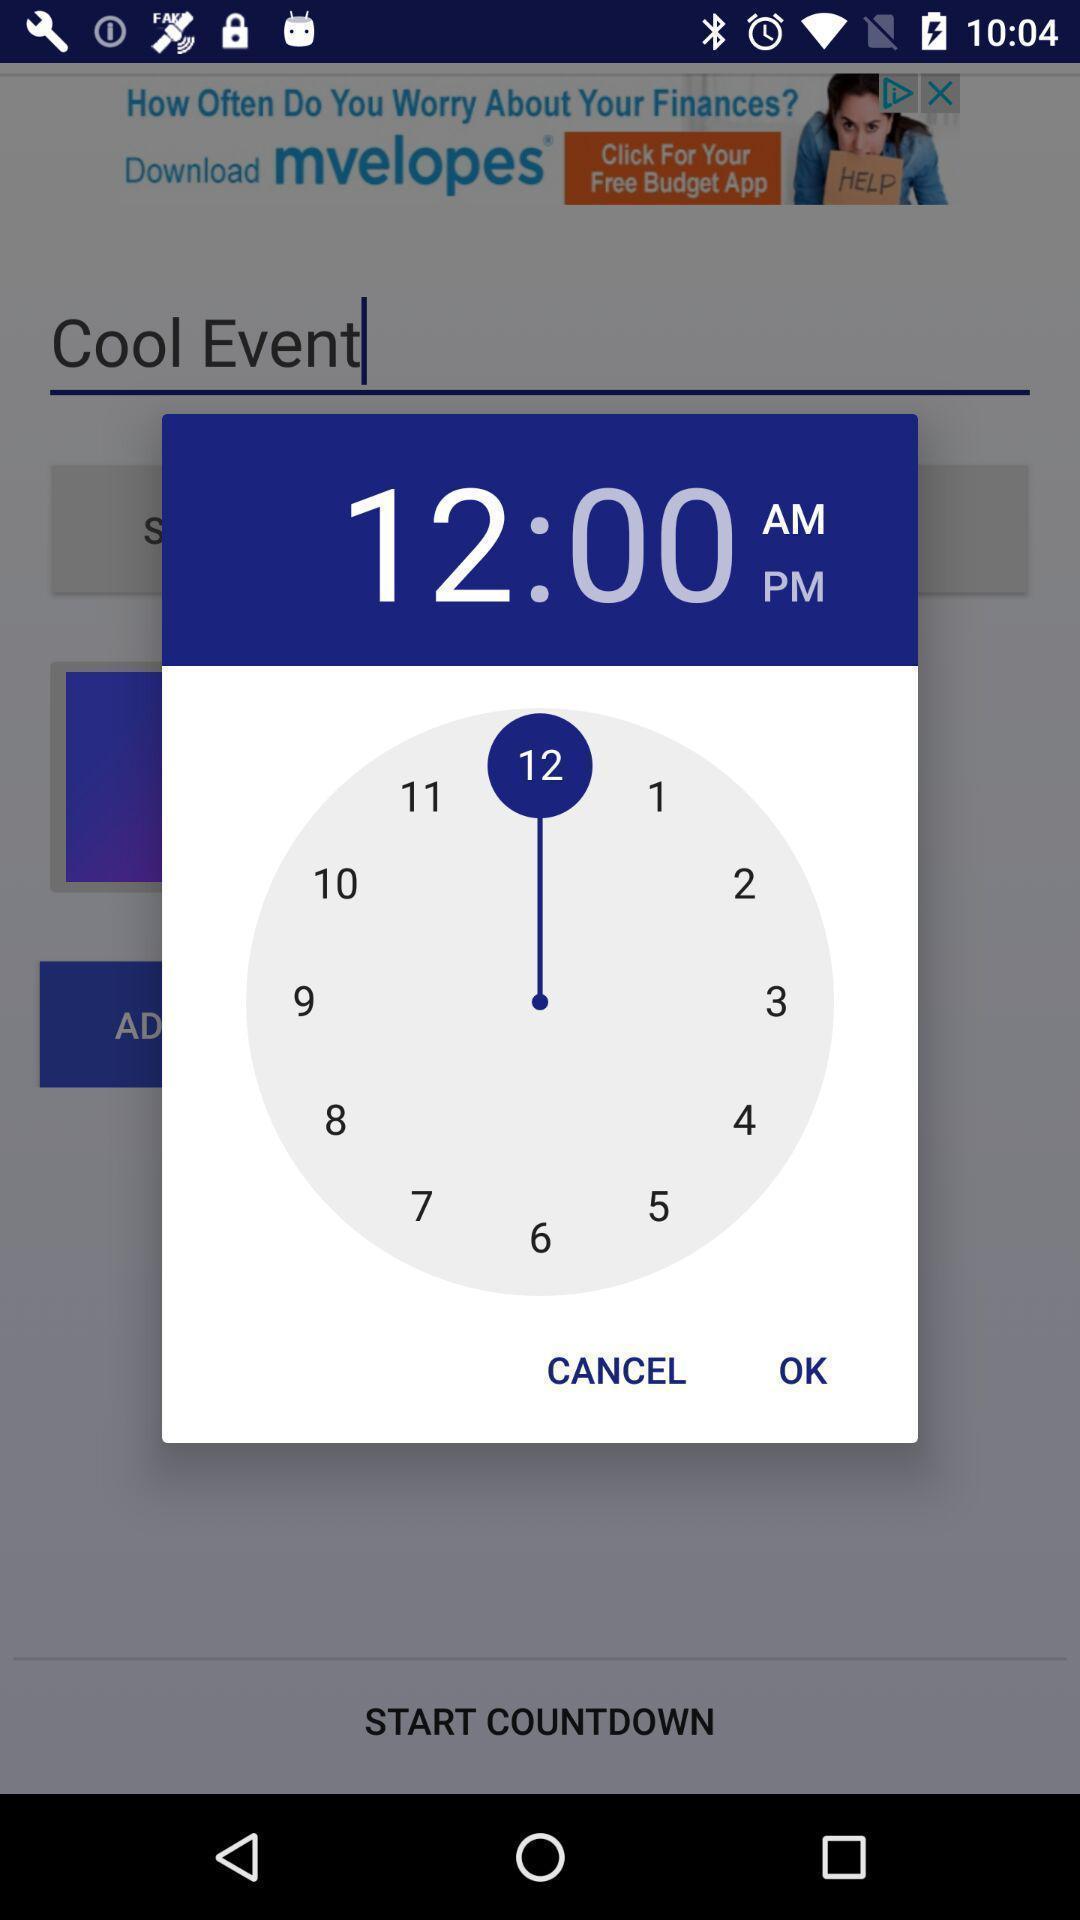Explain what's happening in this screen capture. Pop-up showing to set a timer. 